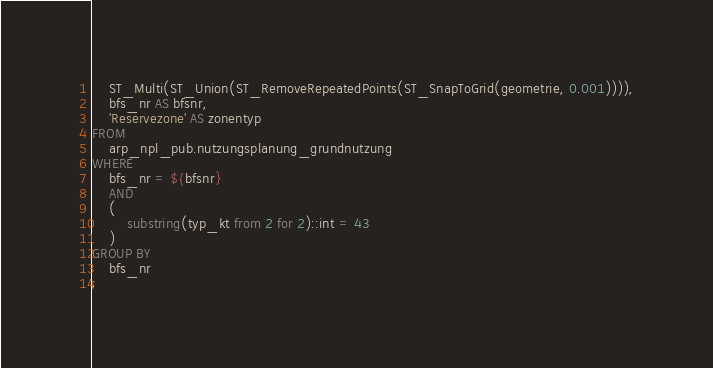<code> <loc_0><loc_0><loc_500><loc_500><_SQL_>	ST_Multi(ST_Union(ST_RemoveRepeatedPoints(ST_SnapToGrid(geometrie, 0.001)))),
	bfs_nr AS bfsnr,
	'Reservezone' AS zonentyp
FROM 
	arp_npl_pub.nutzungsplanung_grundnutzung 
WHERE 
	bfs_nr = ${bfsnr}
	AND 
	(
		substring(typ_kt from 2 for 2)::int = 43
	)
GROUP BY
	bfs_nr
;
</code> 